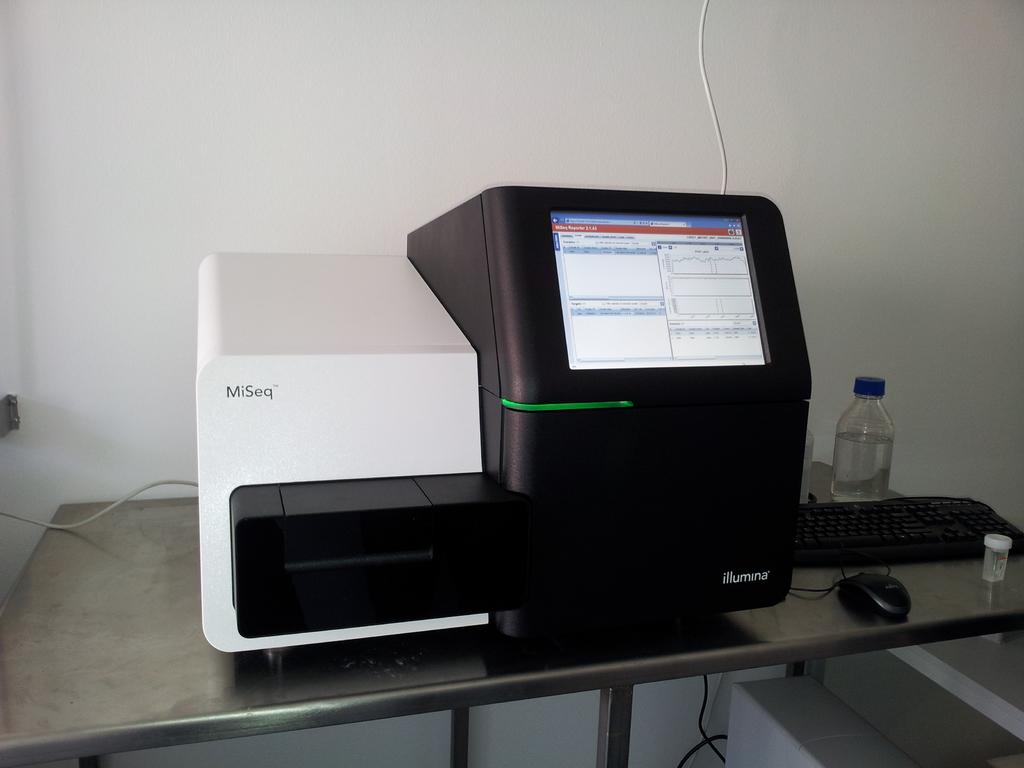What object is located on the table in the image? There is a machine on the table. What else can be seen on the table? There is a bottle, a keyboard, and a mouse on the table. What is the purpose of the keyboard and mouse? The keyboard and mouse are likely used for inputting commands into the machine. What is visible in the background of the image? There is a wall visible in the image. What type of voyage is being planned on the table in the image? There is no indication of a voyage being planned in the image; it features a machine, bottle, keyboard, and mouse on a table with a wall visible in the background. 